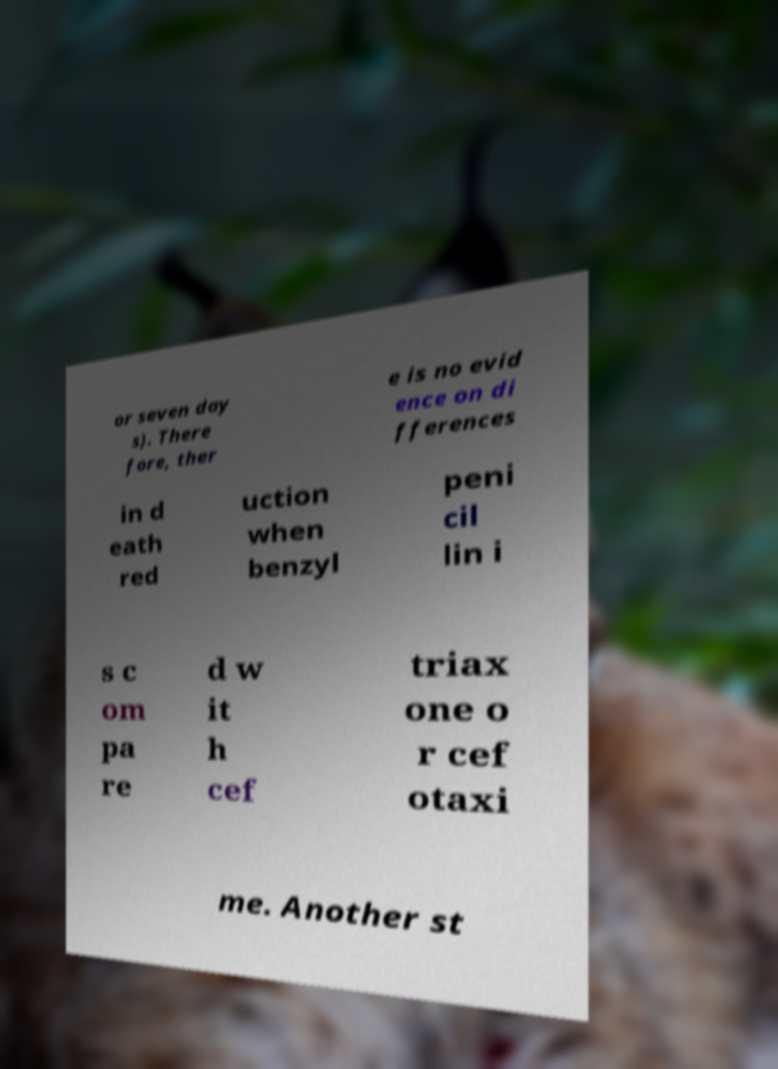What messages or text are displayed in this image? I need them in a readable, typed format. or seven day s). There fore, ther e is no evid ence on di fferences in d eath red uction when benzyl peni cil lin i s c om pa re d w it h cef triax one o r cef otaxi me. Another st 